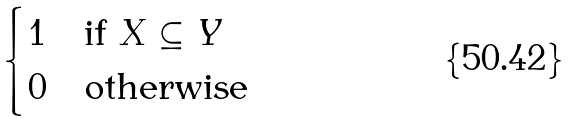<formula> <loc_0><loc_0><loc_500><loc_500>\begin{cases} 1 & \text {if $X\subseteq Y$} \\ 0 & \text {otherwise} \end{cases}</formula> 